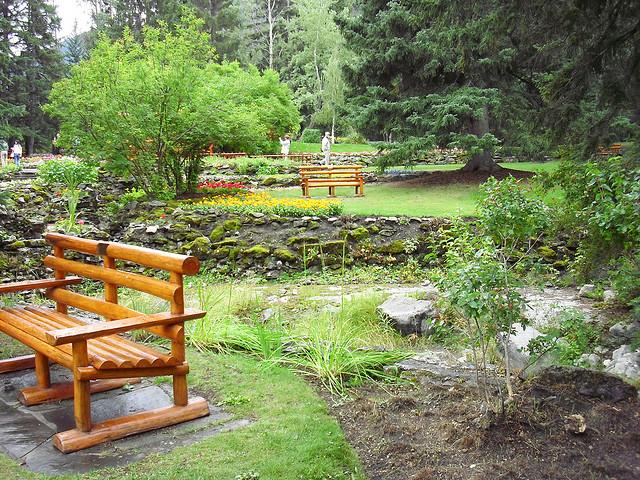What color is the bench on the left?
Quick response, please. Brown. Does the tree go from one end of the picture to the other?
Give a very brief answer. No. How many benches are depicted?
Give a very brief answer. 2. What type of material is the fence made of?
Be succinct. Wood. 